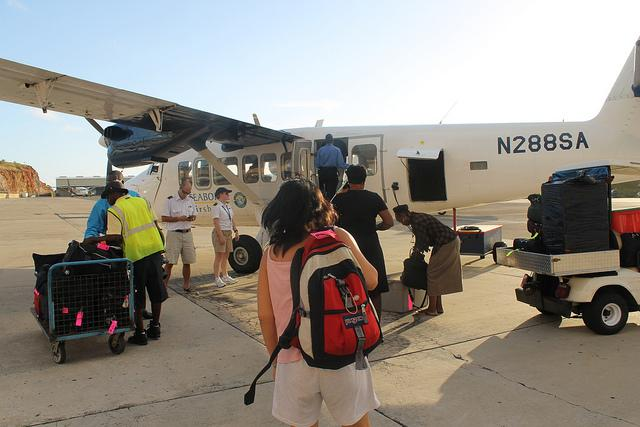Where do the people wearing white shirts work?

Choices:
A) government
B) airplane
C) sewer
D) golf course airplane 